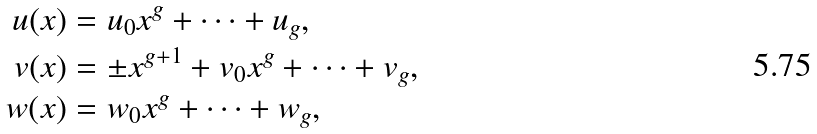<formula> <loc_0><loc_0><loc_500><loc_500>u ( x ) & = u _ { 0 } x ^ { g } + \dots + u _ { g } , \\ v ( x ) & = \pm x ^ { g + 1 } + v _ { 0 } x ^ { g } + \dots + v _ { g } , \\ w ( x ) & = w _ { 0 } x ^ { g } + \dots + w _ { g } ,</formula> 